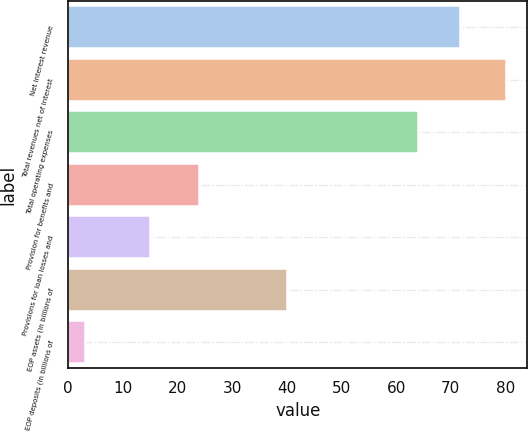<chart> <loc_0><loc_0><loc_500><loc_500><bar_chart><fcel>Net interest revenue<fcel>Total revenues net of interest<fcel>Total operating expenses<fcel>Provision for benefits and<fcel>Provisions for loan losses and<fcel>EOP assets (in billions of<fcel>EOP deposits (in billions of<nl><fcel>71.7<fcel>80<fcel>64<fcel>24<fcel>15<fcel>40<fcel>3<nl></chart> 